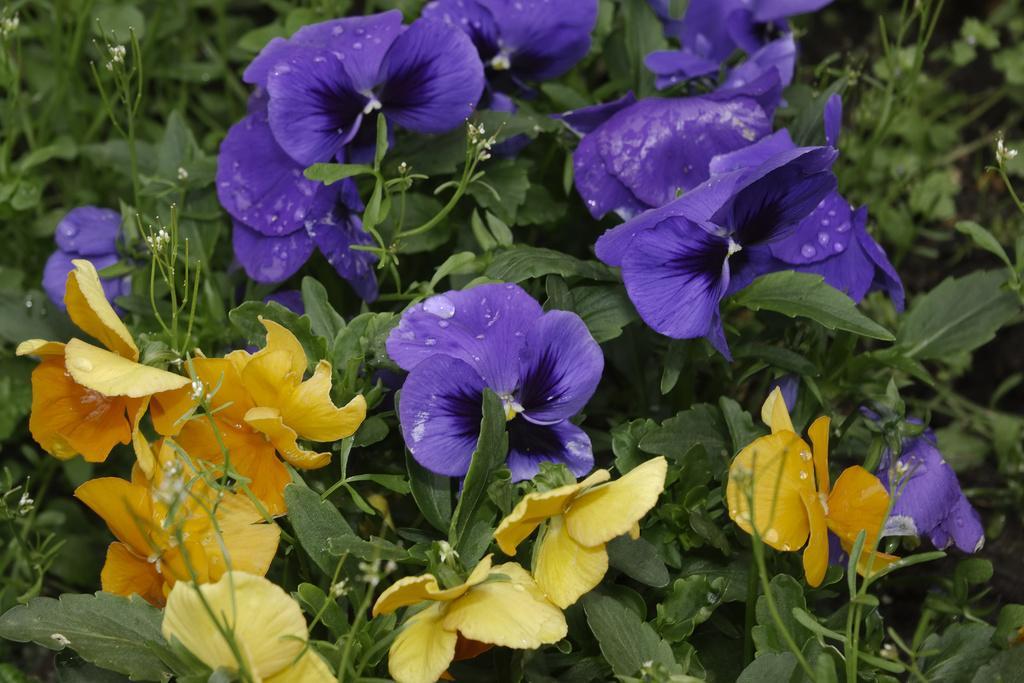Describe this image in one or two sentences. In the image there are many flower plants on which some flowers are yellow in color and remaining are purple color. 